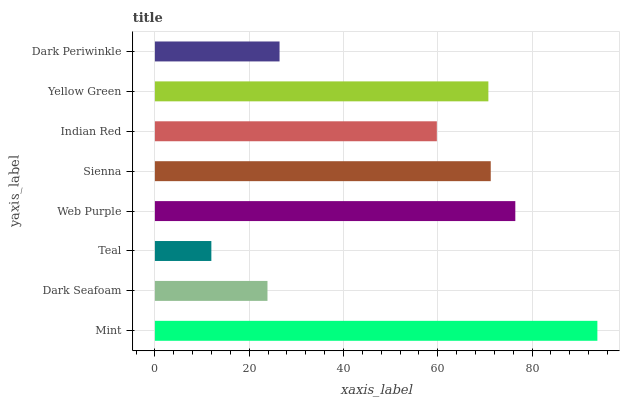Is Teal the minimum?
Answer yes or no. Yes. Is Mint the maximum?
Answer yes or no. Yes. Is Dark Seafoam the minimum?
Answer yes or no. No. Is Dark Seafoam the maximum?
Answer yes or no. No. Is Mint greater than Dark Seafoam?
Answer yes or no. Yes. Is Dark Seafoam less than Mint?
Answer yes or no. Yes. Is Dark Seafoam greater than Mint?
Answer yes or no. No. Is Mint less than Dark Seafoam?
Answer yes or no. No. Is Yellow Green the high median?
Answer yes or no. Yes. Is Indian Red the low median?
Answer yes or no. Yes. Is Teal the high median?
Answer yes or no. No. Is Mint the low median?
Answer yes or no. No. 